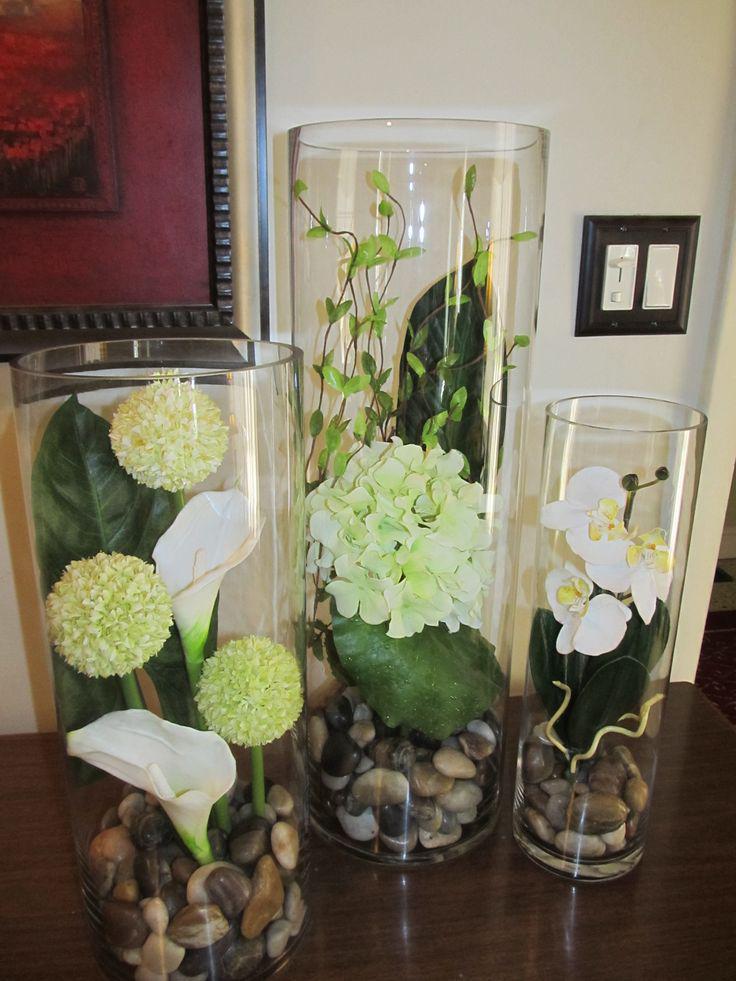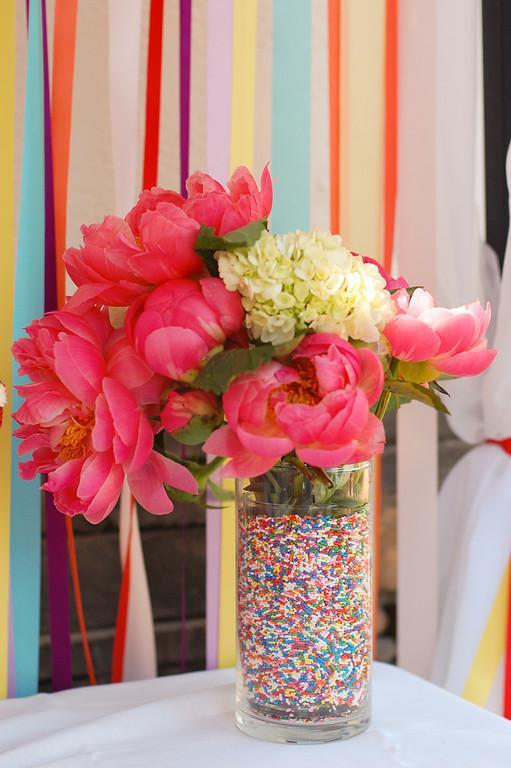The first image is the image on the left, the second image is the image on the right. Assess this claim about the two images: "One image includes a clear glass vase containing only bright yellow flowers standing in water.". Correct or not? Answer yes or no. No. 